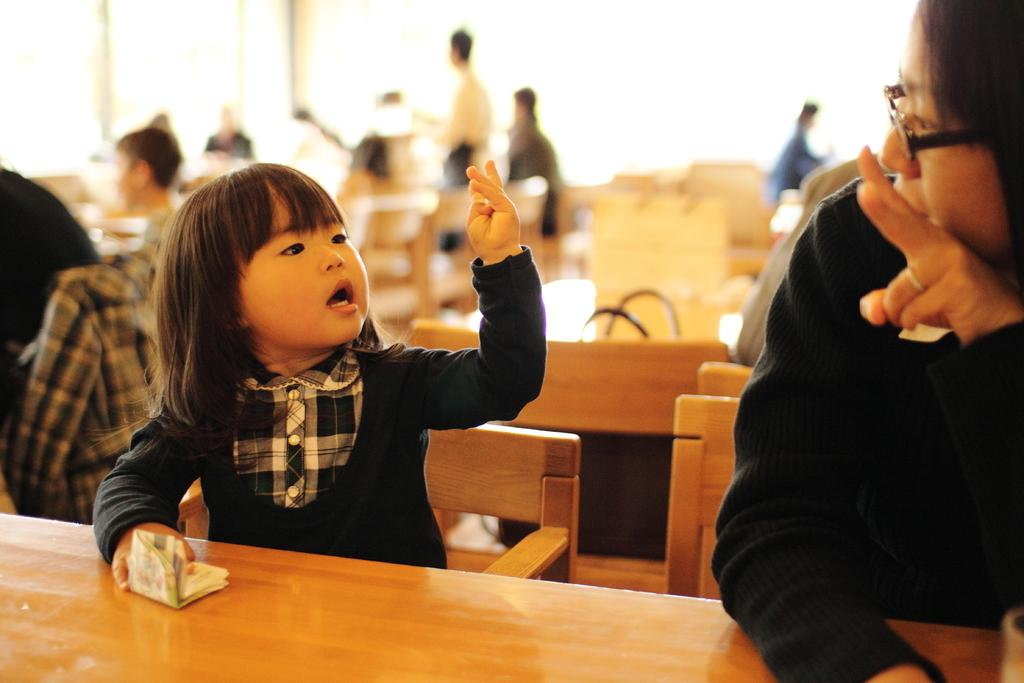What are the people in the image doing? The people in the image are sitting on chairs near a table. What can be seen in the background of the image? In the background, there are pillars, chairs, and tables. How can you describe the clothing of one of the individuals in the image? One girl is wearing a black sweater. What summer activity are the people participating in, as seen in the image? The image does not depict a summer activity, nor does it provide any information about the season. 